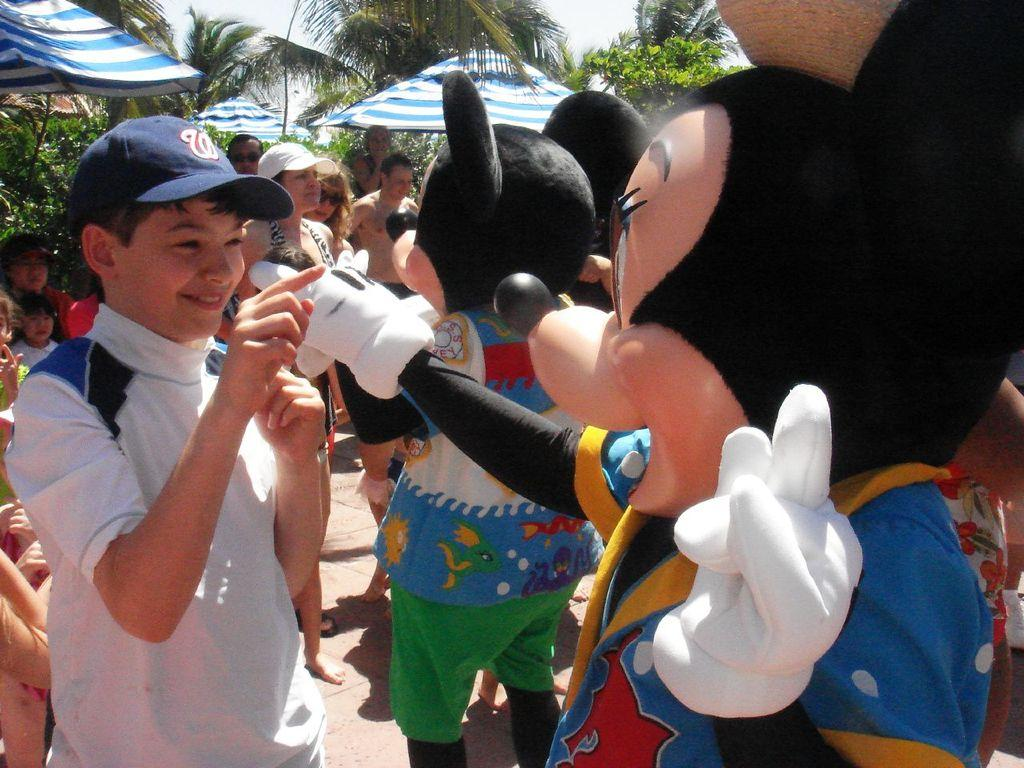What type of characters can be seen in the image? There are clowns in the image. What else can be seen in the image besides the clowns? There are people standing in the image. What can be seen in the background of the image? There are parasols and trees in the background of the image. What is visible in the sky in the image? The sky is visible in the background of the image. What degree is required to understand the pollution in the image? There is no mention of pollution in the image, so a degree is not required to understand it. 